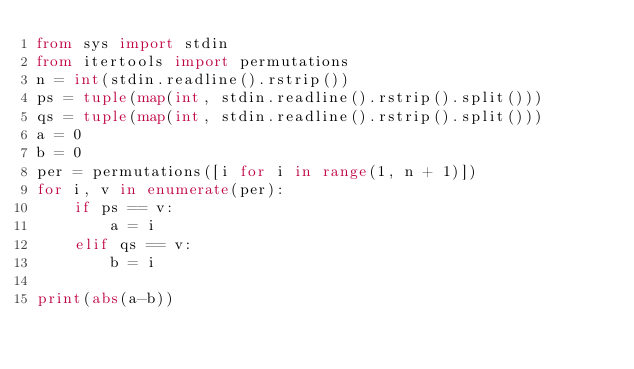<code> <loc_0><loc_0><loc_500><loc_500><_Python_>from sys import stdin
from itertools import permutations
n = int(stdin.readline().rstrip())
ps = tuple(map(int, stdin.readline().rstrip().split()))
qs = tuple(map(int, stdin.readline().rstrip().split()))
a = 0
b = 0
per = permutations([i for i in range(1, n + 1)])
for i, v in enumerate(per):
    if ps == v:
        a = i
    elif qs == v:
        b = i

print(abs(a-b))
</code> 